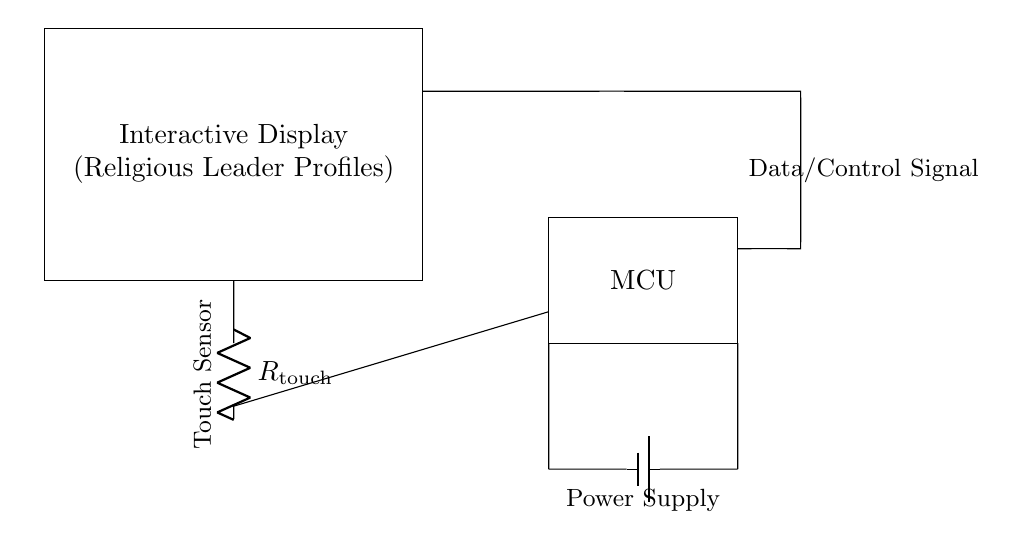What does the rectangle represent? The rectangle in the circuit represents the interactive display, where users can view religious leader profiles. This is indicated by the label "Interactive Display" inside the rectangle.
Answer: Interactive Display What component is labeled with R_touch? The labeled component R_touch in the circuit represents a resistor that functions as a touch sensor. This is shown in the lower left section of the circuit diagram.
Answer: Resistor What type of device is represented by the MCU label? The MCU label stands for Microcontroller Unit, which is represented in the middle right part of the circuit. The rectangle surrounding the label denotes the microcontroller responsible for processing signals.
Answer: Microcontroller How many components are directly connected to the power supply? There are two components directly connected to the power supply: the microcontroller and the resistor. They are connected to the positive terminal of the power supply, indicating these components require power for operation.
Answer: Two What is the function of the touch sensor in this circuit? The touch sensor detects user interaction with the display. It connects to the microcontroller, which processes the touch input to display relevant information about religious leaders. This information is vital for user interaction with the interactive display.
Answer: User interaction What is the signal type transmitted from the MCU to the display? The data/control signal is transmitted from the Microcontroller Unit (MCU) to the interactive display. This signal is crucial for updating the display according to user interactions detected by the touch sensor.
Answer: Data/Control Signal How is power supplied to the touch-sensitive circuit? Power is supplied by a battery, as shown in the circuit diagram. The battery feeds energy to both the microcontroller and the touch sensor, enabling them to function correctly.
Answer: Battery 